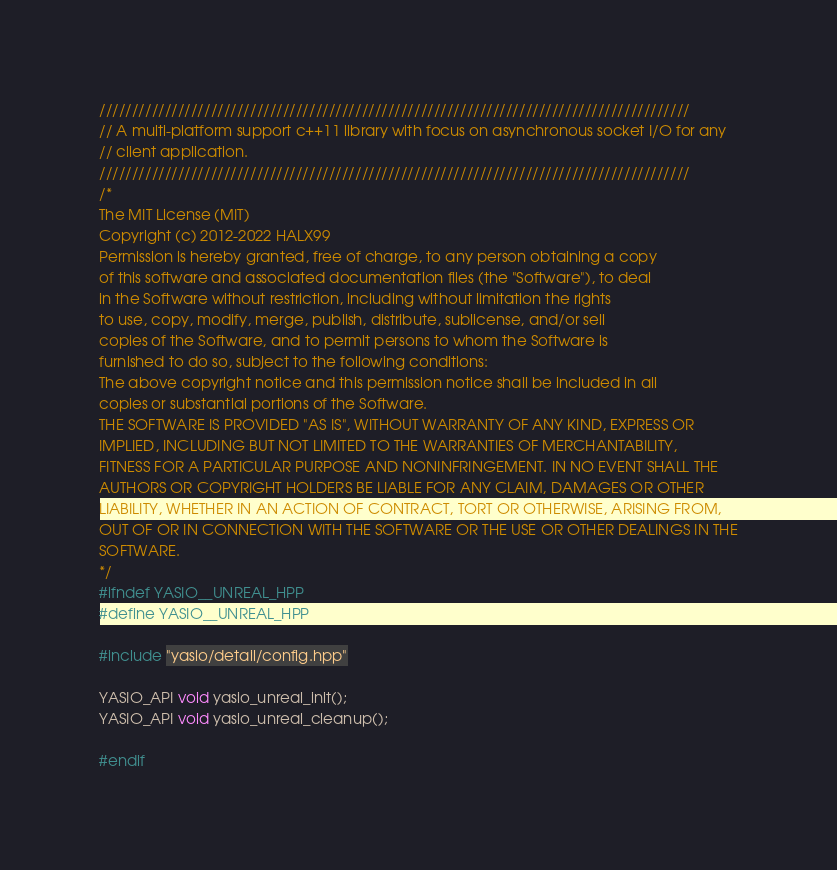<code> <loc_0><loc_0><loc_500><loc_500><_C++_>//////////////////////////////////////////////////////////////////////////////////////////
// A multi-platform support c++11 library with focus on asynchronous socket I/O for any 
// client application.
//////////////////////////////////////////////////////////////////////////////////////////
/*
The MIT License (MIT)
Copyright (c) 2012-2022 HALX99
Permission is hereby granted, free of charge, to any person obtaining a copy
of this software and associated documentation files (the "Software"), to deal
in the Software without restriction, including without limitation the rights
to use, copy, modify, merge, publish, distribute, sublicense, and/or sell
copies of the Software, and to permit persons to whom the Software is
furnished to do so, subject to the following conditions:
The above copyright notice and this permission notice shall be included in all
copies or substantial portions of the Software.
THE SOFTWARE IS PROVIDED "AS IS", WITHOUT WARRANTY OF ANY KIND, EXPRESS OR
IMPLIED, INCLUDING BUT NOT LIMITED TO THE WARRANTIES OF MERCHANTABILITY,
FITNESS FOR A PARTICULAR PURPOSE AND NONINFRINGEMENT. IN NO EVENT SHALL THE
AUTHORS OR COPYRIGHT HOLDERS BE LIABLE FOR ANY CLAIM, DAMAGES OR OTHER
LIABILITY, WHETHER IN AN ACTION OF CONTRACT, TORT OR OTHERWISE, ARISING FROM,
OUT OF OR IN CONNECTION WITH THE SOFTWARE OR THE USE OR OTHER DEALINGS IN THE
SOFTWARE.
*/
#ifndef YASIO__UNREAL_HPP
#define YASIO__UNREAL_HPP

#include "yasio/detail/config.hpp"

YASIO_API void yasio_unreal_init();
YASIO_API void yasio_unreal_cleanup();

#endif
</code> 